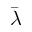<formula> <loc_0><loc_0><loc_500><loc_500>\bar { \lambda }</formula> 